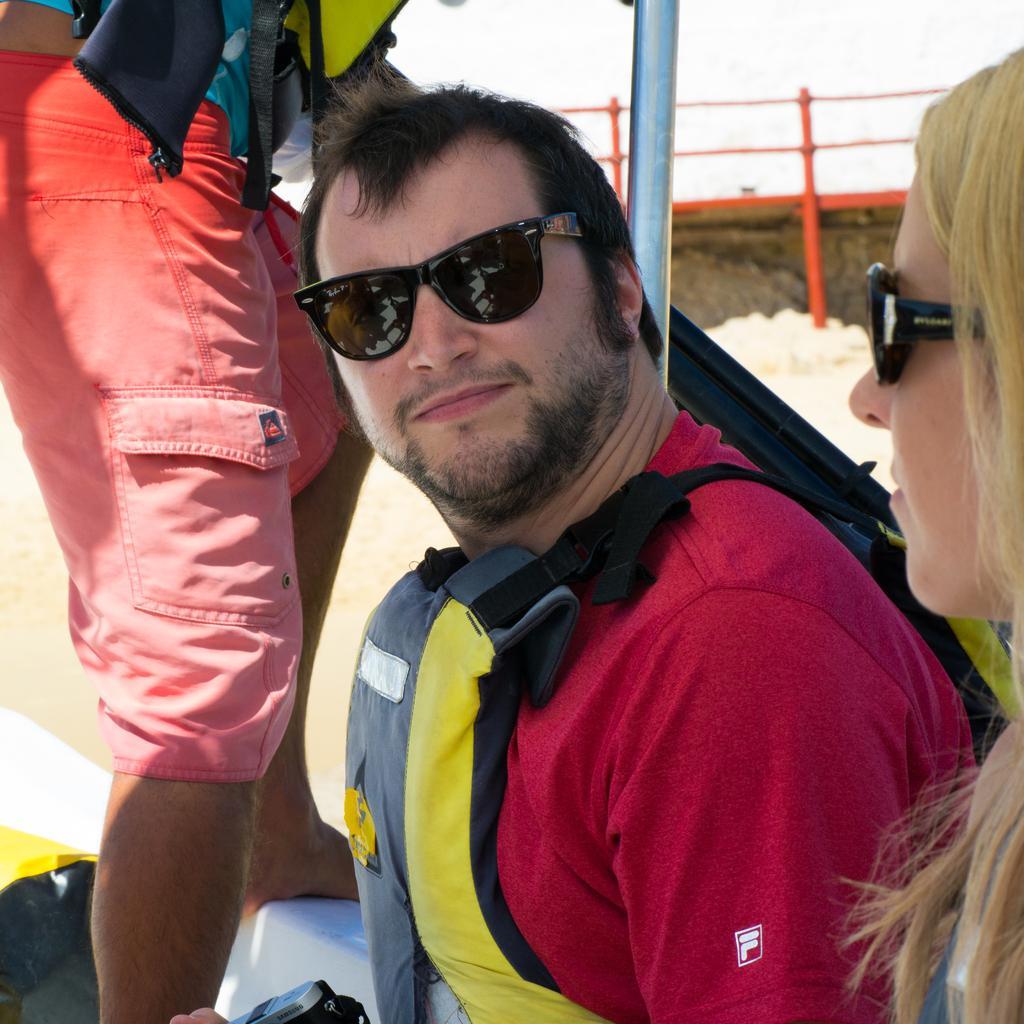Could you give a brief overview of what you see in this image? In this picture we can observe a person wearing a red color T shirt and a life jacket. He is wearing spectacles. On the right side there is a woman wearing spectacles. On the left side we can observe a person standing. In the background there is an orange color railing. 